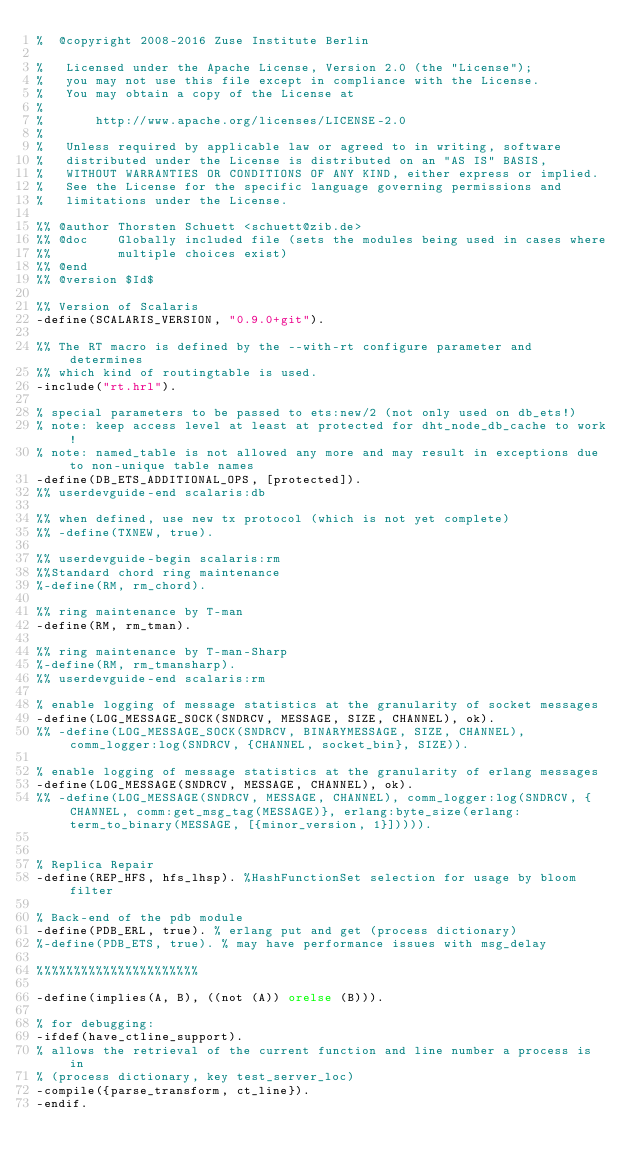<code> <loc_0><loc_0><loc_500><loc_500><_Erlang_>%  @copyright 2008-2016 Zuse Institute Berlin

%   Licensed under the Apache License, Version 2.0 (the "License");
%   you may not use this file except in compliance with the License.
%   You may obtain a copy of the License at
%
%       http://www.apache.org/licenses/LICENSE-2.0
%
%   Unless required by applicable law or agreed to in writing, software
%   distributed under the License is distributed on an "AS IS" BASIS,
%   WITHOUT WARRANTIES OR CONDITIONS OF ANY KIND, either express or implied.
%   See the License for the specific language governing permissions and
%   limitations under the License.

%% @author Thorsten Schuett <schuett@zib.de>
%% @doc    Globally included file (sets the modules being used in cases where
%%         multiple choices exist)
%% @end
%% @version $Id$

%% Version of Scalaris
-define(SCALARIS_VERSION, "0.9.0+git").

%% The RT macro is defined by the --with-rt configure parameter and determines
%% which kind of routingtable is used.
-include("rt.hrl").

% special parameters to be passed to ets:new/2 (not only used on db_ets!)
% note: keep access level at least at protected for dht_node_db_cache to work!
% note: named_table is not allowed any more and may result in exceptions due to non-unique table names
-define(DB_ETS_ADDITIONAL_OPS, [protected]).
%% userdevguide-end scalaris:db

%% when defined, use new tx protocol (which is not yet complete)
%% -define(TXNEW, true).

%% userdevguide-begin scalaris:rm
%%Standard chord ring maintenance
%-define(RM, rm_chord).

%% ring maintenance by T-man
-define(RM, rm_tman).

%% ring maintenance by T-man-Sharp
%-define(RM, rm_tmansharp).
%% userdevguide-end scalaris:rm

% enable logging of message statistics at the granularity of socket messages
-define(LOG_MESSAGE_SOCK(SNDRCV, MESSAGE, SIZE, CHANNEL), ok).
%% -define(LOG_MESSAGE_SOCK(SNDRCV, BINARYMESSAGE, SIZE, CHANNEL), comm_logger:log(SNDRCV, {CHANNEL, socket_bin}, SIZE)).

% enable logging of message statistics at the granularity of erlang messages
-define(LOG_MESSAGE(SNDRCV, MESSAGE, CHANNEL), ok).
%% -define(LOG_MESSAGE(SNDRCV, MESSAGE, CHANNEL), comm_logger:log(SNDRCV, {CHANNEL, comm:get_msg_tag(MESSAGE)}, erlang:byte_size(erlang:term_to_binary(MESSAGE, [{minor_version, 1}])))).


% Replica Repair
-define(REP_HFS, hfs_lhsp). %HashFunctionSet selection for usage by bloom filter

% Back-end of the pdb module
-define(PDB_ERL, true). % erlang put and get (process dictionary)
%-define(PDB_ETS, true). % may have performance issues with msg_delay

%%%%%%%%%%%%%%%%%%%%%%

-define(implies(A, B), ((not (A)) orelse (B))).

% for debugging:
-ifdef(have_ctline_support).
% allows the retrieval of the current function and line number a process is in
% (process dictionary, key test_server_loc)
-compile({parse_transform, ct_line}).
-endif.
</code> 